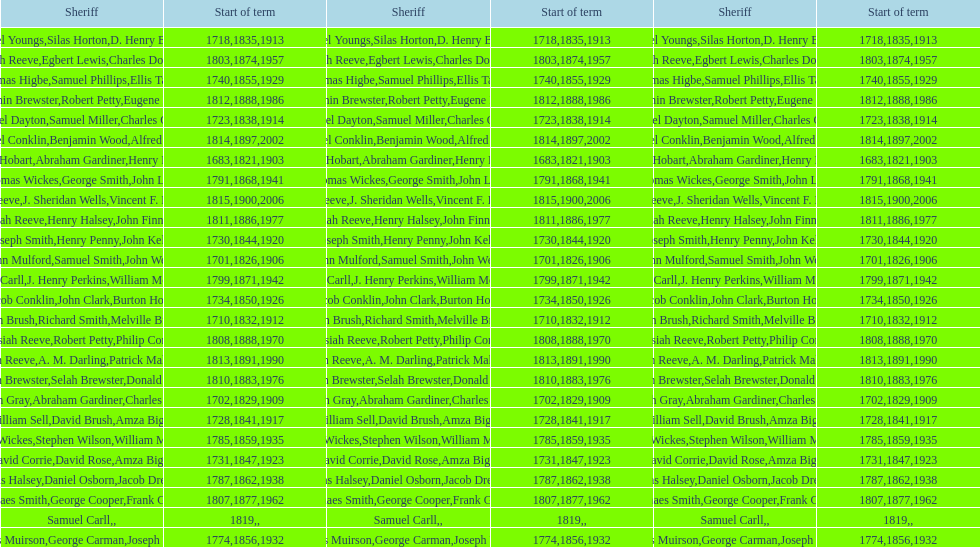Did robert petty serve before josiah reeve? No. 